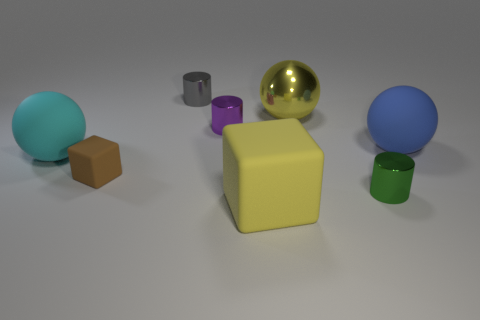Add 2 tiny green metal cylinders. How many objects exist? 10 Subtract all large rubber balls. How many balls are left? 1 Subtract all purple cylinders. How many cylinders are left? 2 Subtract 2 cubes. How many cubes are left? 0 Subtract all green spheres. How many blue cylinders are left? 0 Subtract all large blue matte blocks. Subtract all cylinders. How many objects are left? 5 Add 8 cyan matte things. How many cyan matte things are left? 9 Add 5 large blue metallic cubes. How many large blue metallic cubes exist? 5 Subtract 1 blue balls. How many objects are left? 7 Subtract all spheres. How many objects are left? 5 